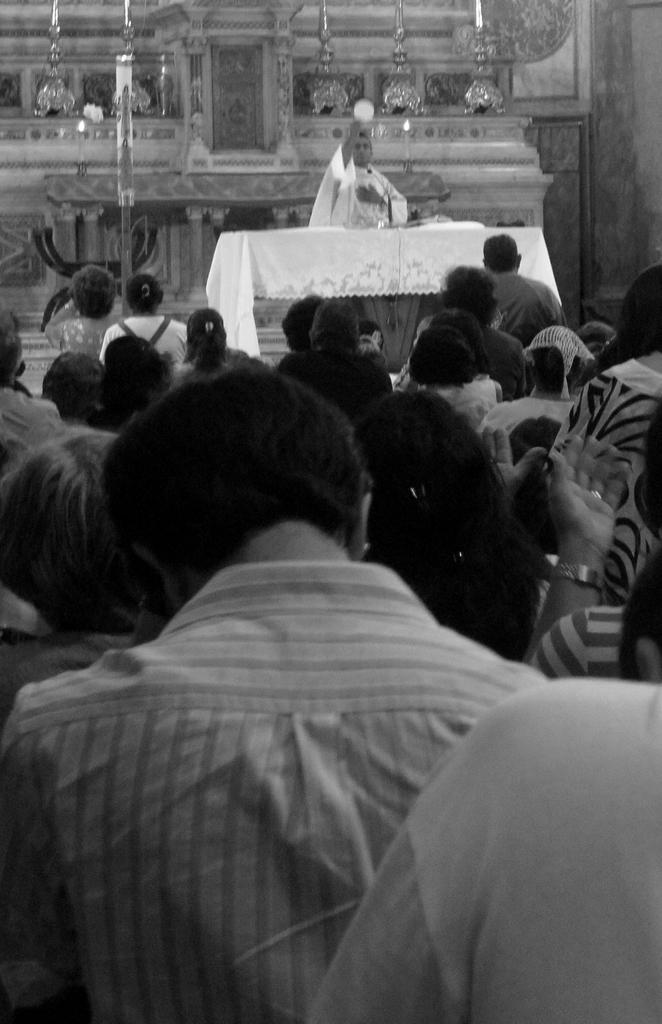Could you give a brief overview of what you see in this image? This image is taken indoors. This image is a black and white image. In the middle of the image there are many people. In the background there is a wall with carvings on it. There are a few pillars. There are a few lamps. There is a table with a tablecloth and a few things on it. A man is standing on the floor. 